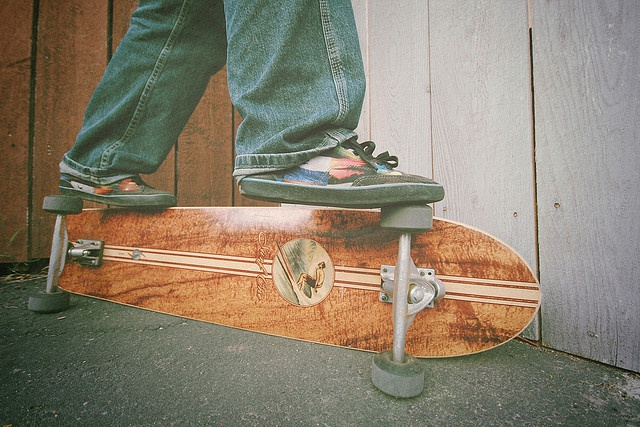Describe the objects in this image and their specific colors. I can see skateboard in maroon, tan, brown, and salmon tones and people in maroon, teal, gray, darkgray, and darkgreen tones in this image. 